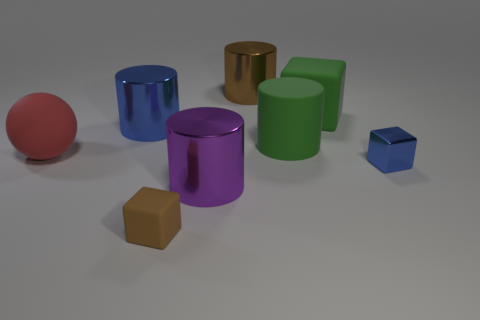What is the significance of the colors and shapes used here? The colors and shapes might symbolize a variety of concepts. The vibrant colors could represent diversity or creativity, while the different geometric shapes might signify the various elements that come together to form a cohesive whole. Alternatively, the scene could simply be an abstract arrangement meant to study geometric forms and color contrasts. 